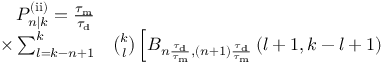Convert formula to latex. <formula><loc_0><loc_0><loc_500><loc_500>\begin{array} { r l } { P _ { n | k } ^ { ( i i ) } = \frac { \tau _ { m } } { \tau _ { d } } } \\ { \times \sum _ { l = k - n + 1 } ^ { k } } & \binom { k } { l } \left [ B _ { n \frac { \tau _ { d } } { \tau _ { m } } , ( n + 1 ) \frac { \tau _ { d } } { \tau _ { m } } } \left ( l + 1 , k - l + 1 \right ) } \end{array}</formula> 